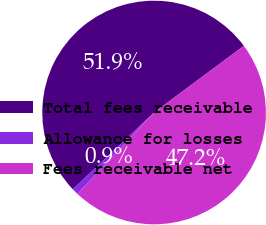<chart> <loc_0><loc_0><loc_500><loc_500><pie_chart><fcel>Total fees receivable<fcel>Allowance for losses<fcel>Fees receivable net<nl><fcel>51.89%<fcel>0.93%<fcel>47.18%<nl></chart> 